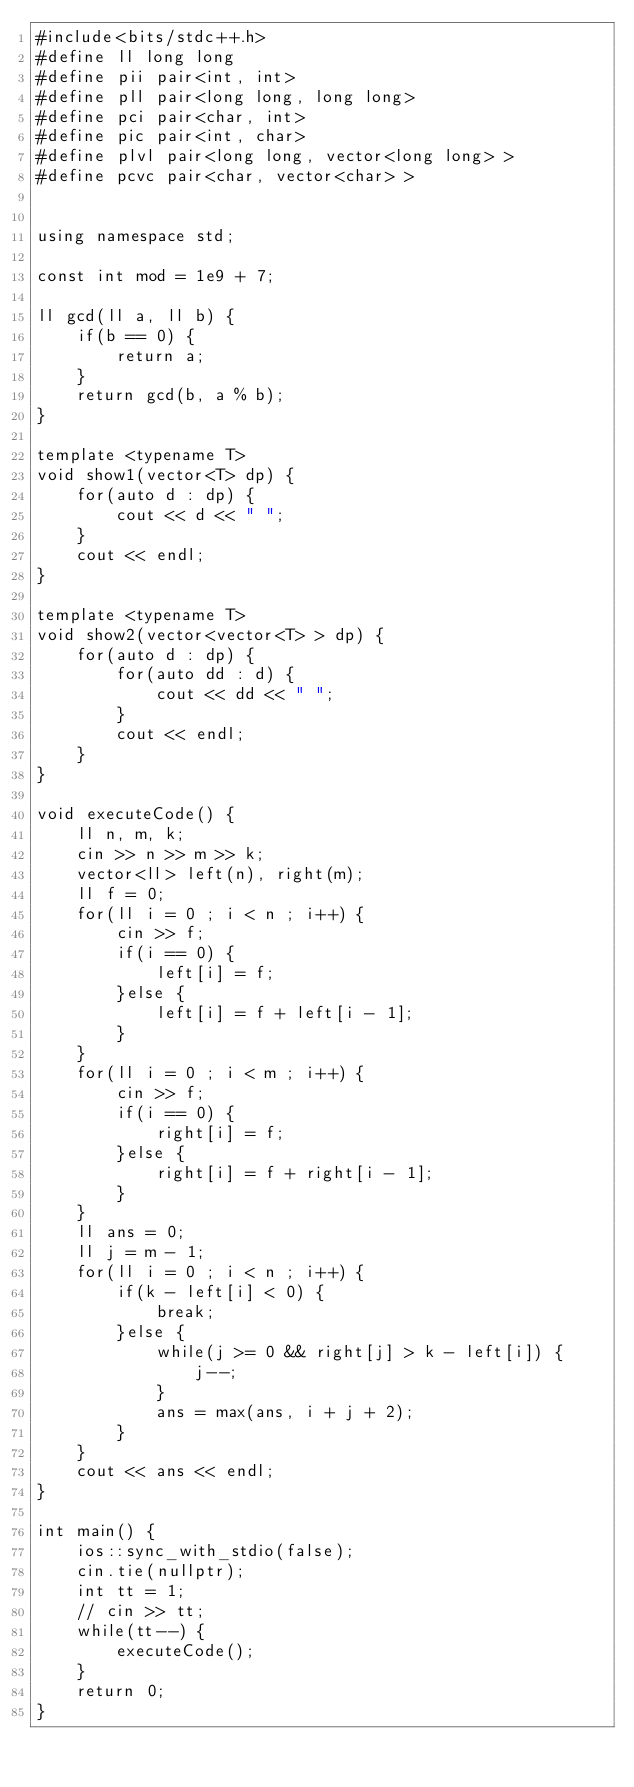Convert code to text. <code><loc_0><loc_0><loc_500><loc_500><_C++_>#include<bits/stdc++.h>
#define ll long long
#define pii pair<int, int>
#define pll pair<long long, long long>
#define pci pair<char, int>
#define pic pair<int, char>
#define plvl pair<long long, vector<long long> >
#define pcvc pair<char, vector<char> >


using namespace std;

const int mod = 1e9 + 7;

ll gcd(ll a, ll b) {
	if(b == 0) {
		return a;
	}
	return gcd(b, a % b);
}

template <typename T>
void show1(vector<T> dp) {
	for(auto d : dp) {
		cout << d << " ";
	}
	cout << endl;
}

template <typename T>
void show2(vector<vector<T> > dp) {
	for(auto d : dp) {
		for(auto dd : d) {
			cout << dd << " ";
		}
		cout << endl;
	}
}

void executeCode() {
	ll n, m, k;
	cin >> n >> m >> k;
	vector<ll> left(n), right(m);
	ll f = 0;
	for(ll i = 0 ; i < n ; i++) {
		cin >> f;
		if(i == 0) {
			left[i] = f;
		}else {
			left[i] = f + left[i - 1];
		}
	}
	for(ll i = 0 ; i < m ; i++) {
		cin >> f;
		if(i == 0) {
			right[i] = f;
		}else {
			right[i] = f + right[i - 1];
		}
	}
	ll ans = 0;
	ll j = m - 1;
	for(ll i = 0 ; i < n ; i++) {
		if(k - left[i] < 0) {
			break;
		}else {
			while(j >= 0 && right[j] > k - left[i]) {
				j--;
			}
			ans = max(ans, i + j + 2);
		}
	}
	cout << ans << endl;
}

int main() {
	ios::sync_with_stdio(false);
    cin.tie(nullptr);
	int tt = 1;
	// cin >> tt;
	while(tt--) {
		executeCode();	
	}
	return 0;
}</code> 